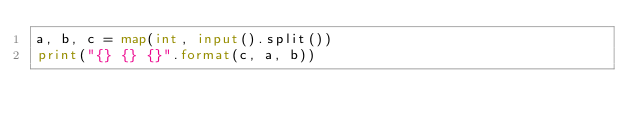Convert code to text. <code><loc_0><loc_0><loc_500><loc_500><_Python_>a, b, c = map(int, input().split())
print("{} {} {}".format(c, a, b))</code> 